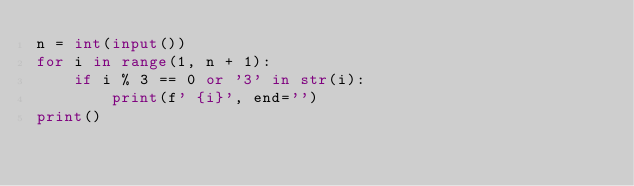Convert code to text. <code><loc_0><loc_0><loc_500><loc_500><_Python_>n = int(input())
for i in range(1, n + 1):
    if i % 3 == 0 or '3' in str(i):
        print(f' {i}', end='')
print()

</code> 